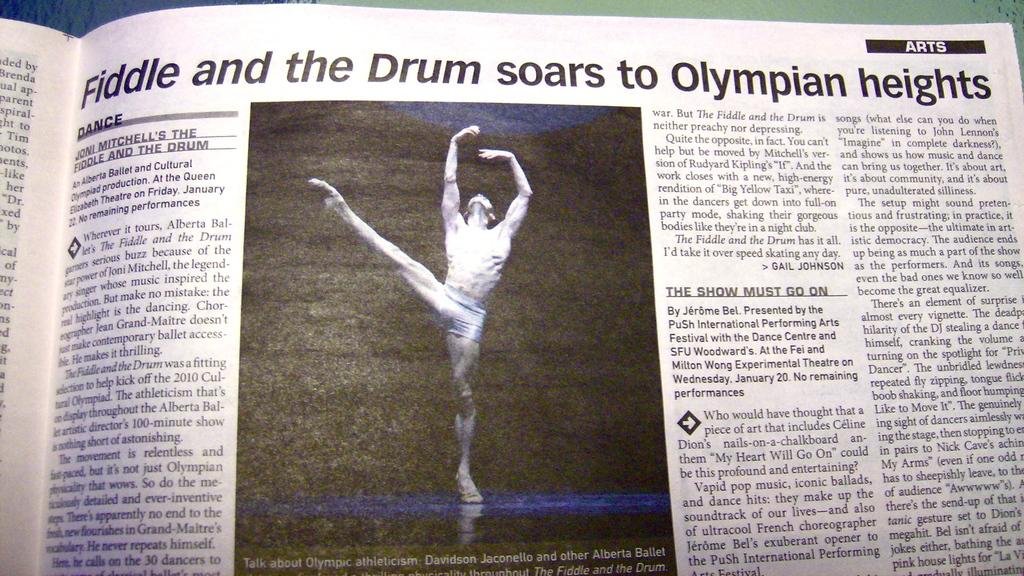Is this about olympians?
Your response must be concise. Yes. 